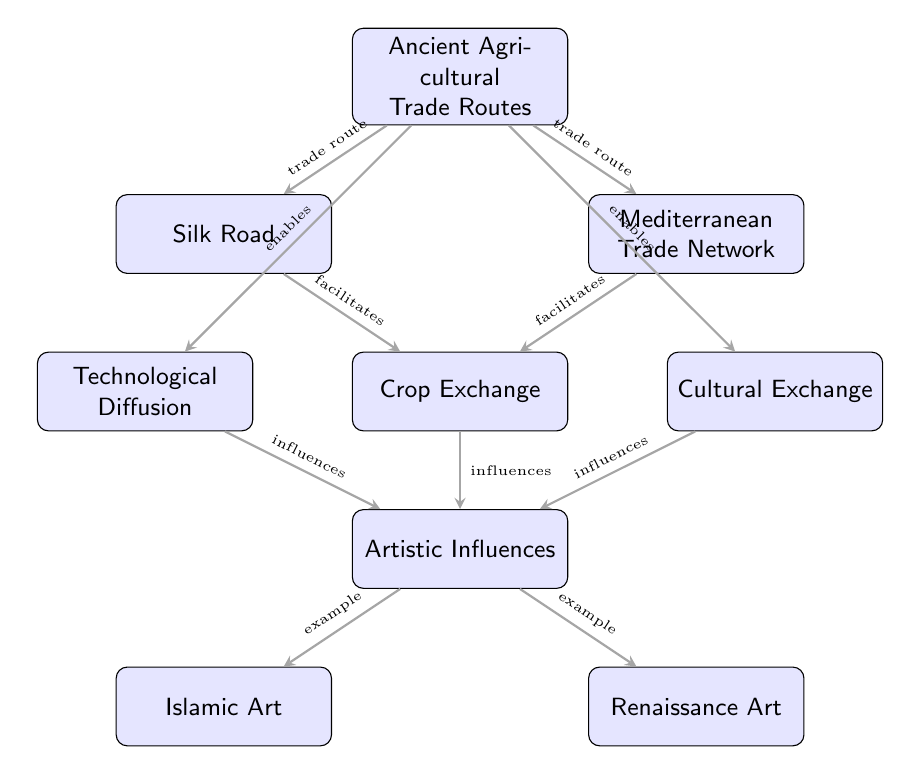What are the two main ancient agricultural trade routes shown in the diagram? The diagram lists the Silk Road and the Mediterranean Trade Network as the two main ancient agricultural trade routes connected to agricultural goods and technologies.
Answer: Silk Road, Mediterranean Trade Network Which node represents the movement of food crops? The node labeled "Crop Exchange" signifies the movement of food crops such as wheat, rice, and spices along trade routes, according to the diagram.
Answer: Crop Exchange How many nodes are there in the diagram? The diagram contains a total of nine nodes, each representing various components related to agricultural trade routes and their impact on art.
Answer: Nine Which type of art is influenced by agricultural advancements in the Islamic world? The diagram indicates that "Islamic Art" is the type of art influenced by agricultural advancements and trade, as shown in the relationships outlined.
Answer: Islamic Art What is the relationship between Crop Exchange and Artistic Influences? The link between "Crop Exchange" and "Artistic Influences" is identified as an "influences" type, meaning that the exchange of crops has a direct impact on the development of artistic styles and techniques.
Answer: Influences How does the Silk Road facilitate crop exchange? The diagram suggests that the Silk Road acts as a pathway that enables the movement of various crops, reinforcing its role in facilitating agricultural trade.
Answer: Enables Which node describes the spread of agricultural technologies? The node "Technological Diffusion" explains the spread of various agricultural technologies through trade routes, as indicated in the diagram.
Answer: Technological Diffusion If cultural exchange is enabled by trade routes, how does it impact art? The diagram illustrates that cultural exchange fosters artistic influences, meaning that the interchange of cultural elements through trade routes enhances artistic expression and styles.
Answer: Fostering artistic influences What type of influence does Crop Exchange have on art? The diagram states that Crop Exchange has an "influences" relationship with Artistic Influences, indicating that the exchange of crops significantly impacts artistic expressions and styles.
Answer: Influences 